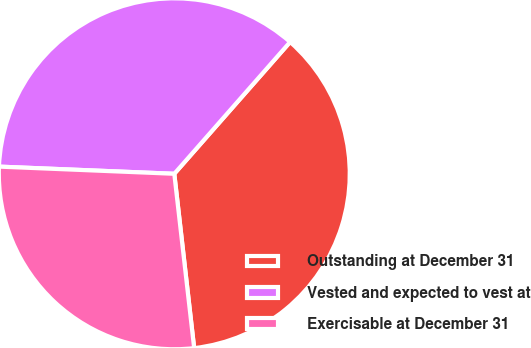Convert chart. <chart><loc_0><loc_0><loc_500><loc_500><pie_chart><fcel>Outstanding at December 31<fcel>Vested and expected to vest at<fcel>Exercisable at December 31<nl><fcel>36.72%<fcel>35.83%<fcel>27.46%<nl></chart> 